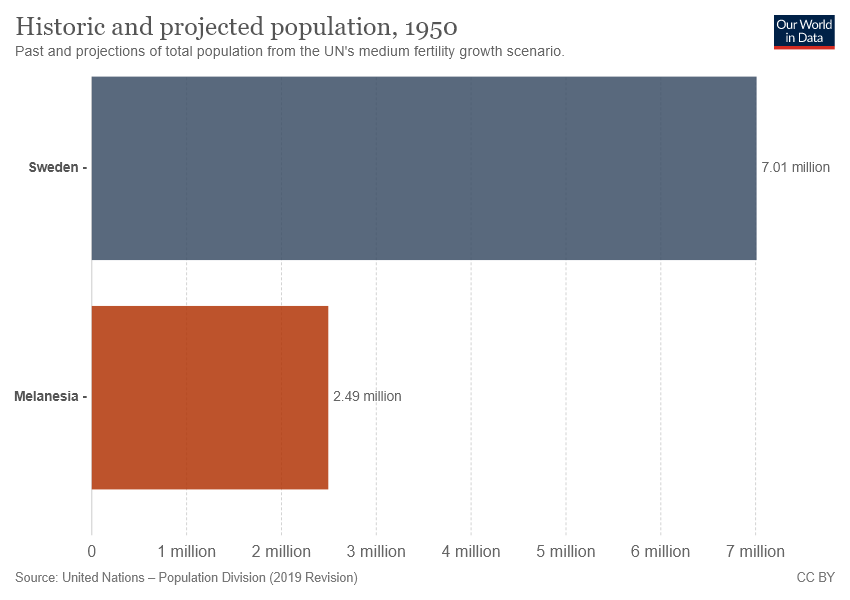Indicate a few pertinent items in this graphic. The longer bar presents Sweden. The ratio between two countries is 2.815261... 